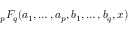Convert formula to latex. <formula><loc_0><loc_0><loc_500><loc_500>{ } _ { p } F _ { q } ( a _ { 1 } , \dots , a _ { p } , b _ { 1 } , \dots , b _ { q } , x )</formula> 